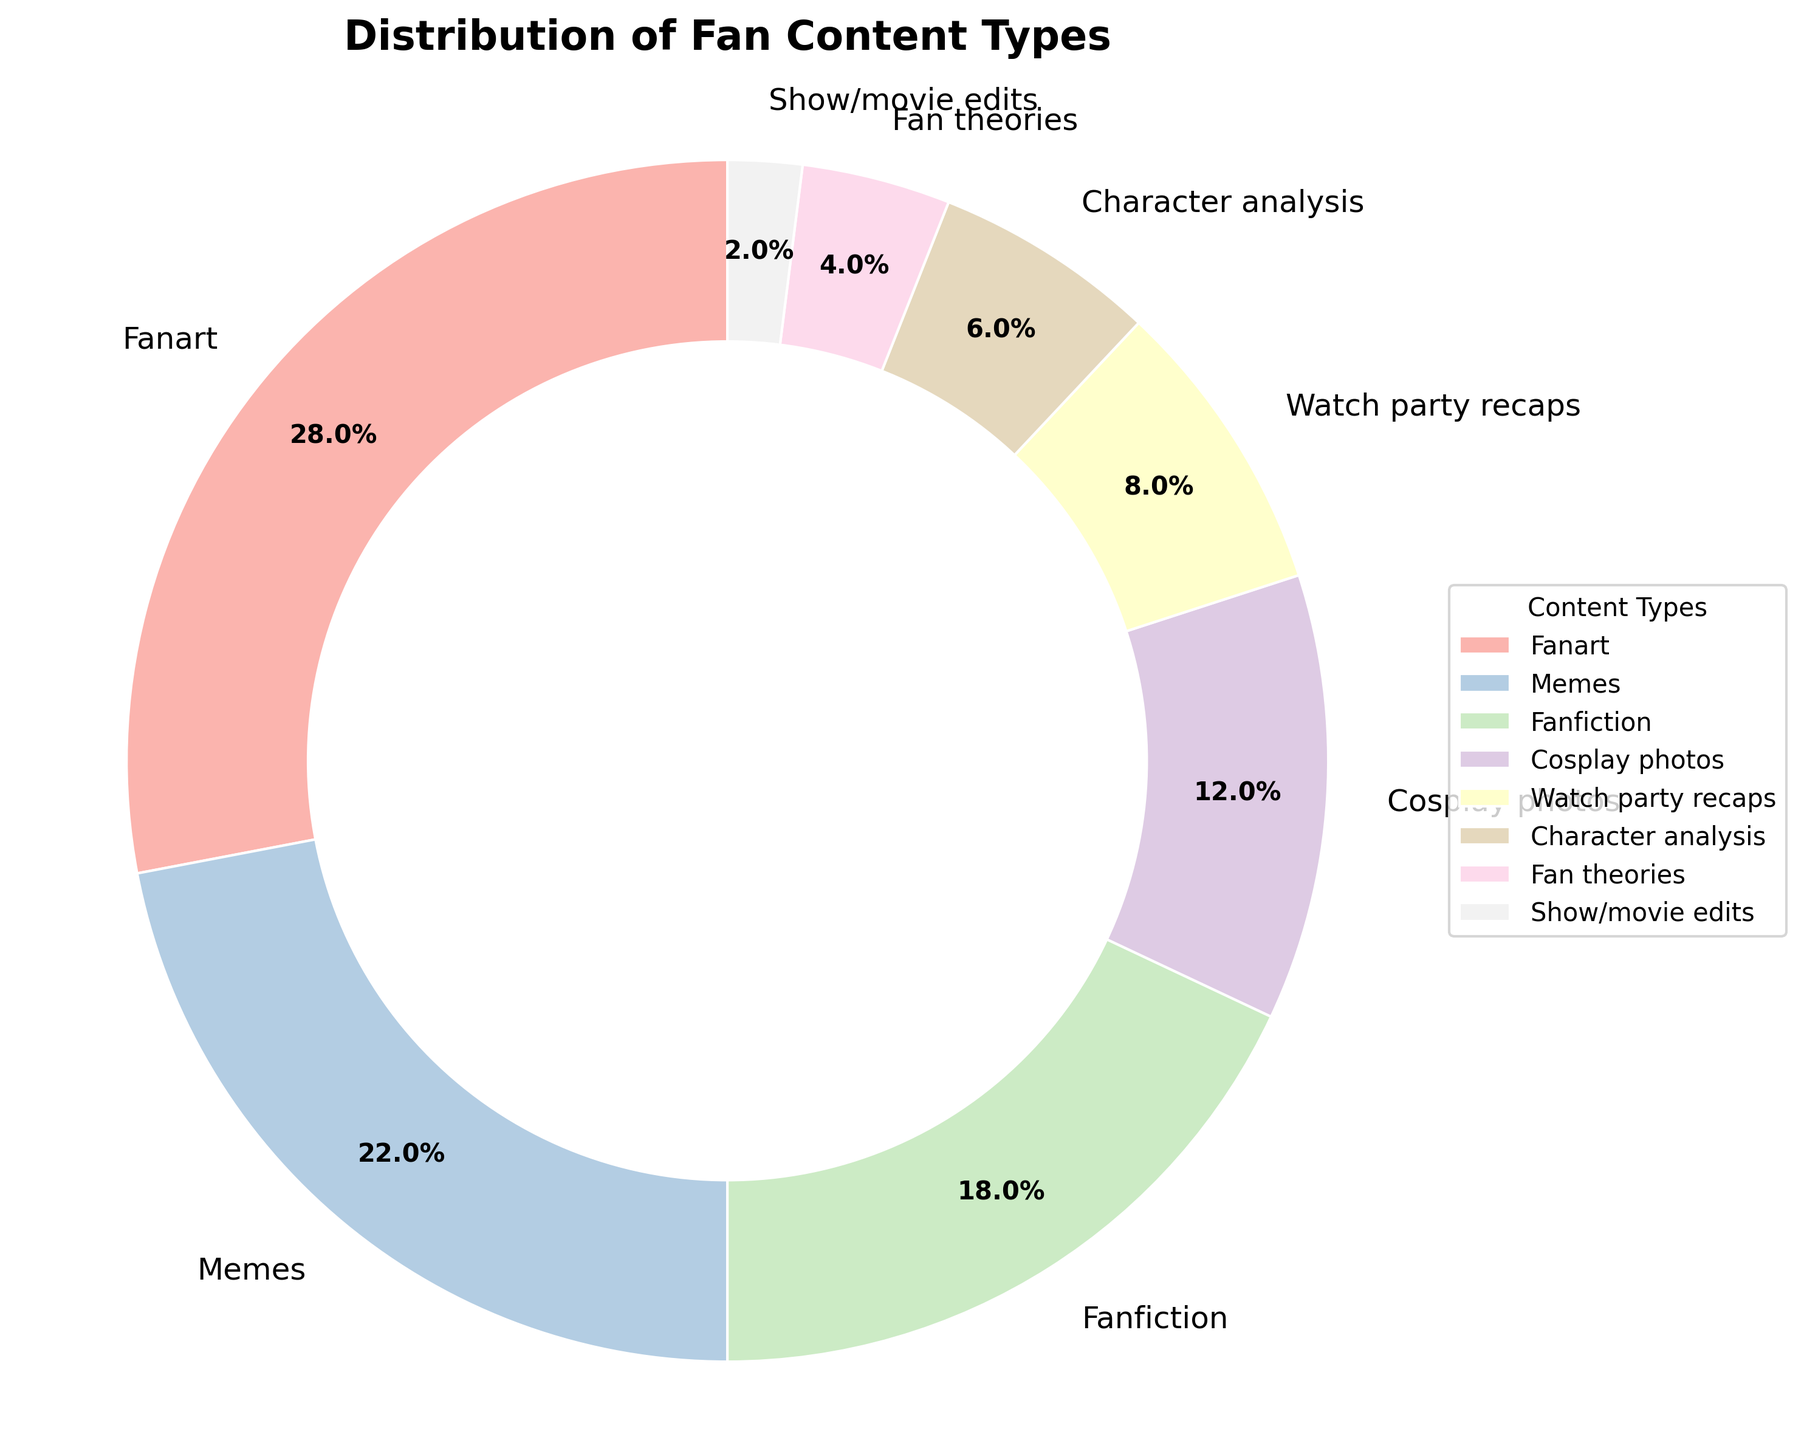What is the most popular type of fan content created as shown in the pie chart? The largest wedge in the pie chart represents the most popular type of fan content. In this case, the fanart section (28%) is the largest among all, indicating it is the most popular type.
Answer: Fanart Which type of fan content has a higher percentage, memes or fanfiction? Comparing the wedges representing memes (22%) and fanfiction (18%) on the pie chart, the memes section is visually larger, indicating a higher percentage.
Answer: Memes What is the combined percentage of fanart and memes? Add the percentages of fanart (28%) and memes (22%) as shown in the pie chart. 28% + 22% = 50%
Answer: 50% How much more popular is fanart compared to cosplay photos? Subtract the percentage of cosplay photos (12%) from that of fanart (28%) as displayed in the pie chart. 28% - 12% = 16%
Answer: 16% Among the least popular content types, which one has the smallest percentage? The pie chart shows the smallest wedge belongs to show/movie edits with 2%.
Answer: Show/movie edits Which has fewer percentages, watch party recaps or character analysis? The chart shows watch party recaps have 8%, whereas character analysis has 6%. Therefore, character analysis has a smaller percentage.
Answer: Character analysis What is the total percentage for fan theories, show/movie edits, and character analysis combined? Sum the percentages of fan theories (4%), show/movie edits (2%), and character analysis (6%). 4% + 2% + 6% = 12%
Answer: 12% Which content types make up less than 10% each? On the pie chart, watch party recaps (8%), character analysis (6%), fan theories (4%), and show/movie edits (2%) are all below 10%.
Answer: Watch party recaps, character analysis, fan theories, show/movie edits Out of fanfiction and watch party recaps, which is created more often? Comparing the wedges, fanfiction has 18% while watch party recaps have 8%. Fanfiction is visibly larger, indicating it is created more often.
Answer: Fanfiction What percentage of the total distribution does cosplay photos and character analysis together make up? Sum the percentages of cosplay photos (12%) and character analysis (6%). 12% + 6% = 18%
Answer: 18% 